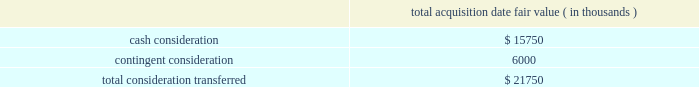Abiomed , inc .
And subsidiaries notes to consolidated financial statements 2014 ( continued ) note 3 .
Acquisitions ( continued ) including the revenues of third-party licensees , or ( ii ) the company 2019s sale of ( a ) ecp , ( b ) all or substantially all of ecp 2019s assets , or ( c ) certain of ecp 2019s patent rights , the company will pay to syscore the lesser of ( x ) one-half of the profits earned from such sale described in the foregoing item ( ii ) , after accounting for the costs of acquiring and operating ecp , or ( y ) $ 15.0 million ( less any previous milestone payment ) .
Ecp 2019s acquisition of ais gmbh aachen innovative solutions in connection with the company 2019s acquisition of ecp , ecp acquired all of the share capital of ais gmbh aachen innovative solutions ( 201cais 201d ) , a limited liability company incorporated in germany , pursuant to a share purchase agreement dated as of june 30 , 2014 , by and among ecp and ais 2019s four individual shareholders .
Ais , based in aachen , germany , holds certain intellectual property useful to ecp 2019s business , and , prior to being acquired by ecp , had licensed such intellectual property to ecp .
The purchase price for the acquisition of ais 2019s share capital was approximately $ 2.8 million in cash , which was provided by the company , and the acquisition closed immediately prior to abiomed europe 2019s acquisition of ecp .
The share purchase agreement contains representations , warranties and closing conditions customary for transactions of its size and nature .
Purchase price allocation the acquisition of ecp and ais was accounted for as a business combination .
The purchase price for the acquisition has been allocated to the assets acquired and liabilities assumed based on their estimated fair values .
The acquisition-date fair value of the consideration transferred is as follows : acquisition date fair value ( in thousands ) .

What portion of total consideration transferred for acquisition of ecp and ais is contingent consideration? 
Computations: (6000 / 21750)
Answer: 0.27586. 